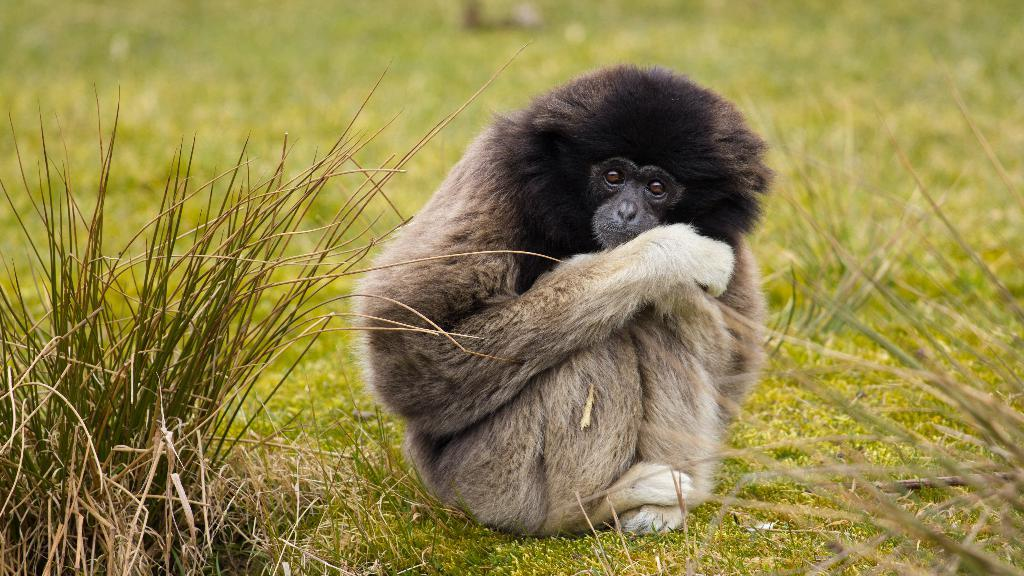What is the main subject in the center of the image? There is an animal in the center of the image. What type of vegetation can be seen at the bottom of the image? There is grass at the bottom of the image. What invention is being used by the animal in the image? There is no invention present in the image; it features a natural setting with an animal and grass. 